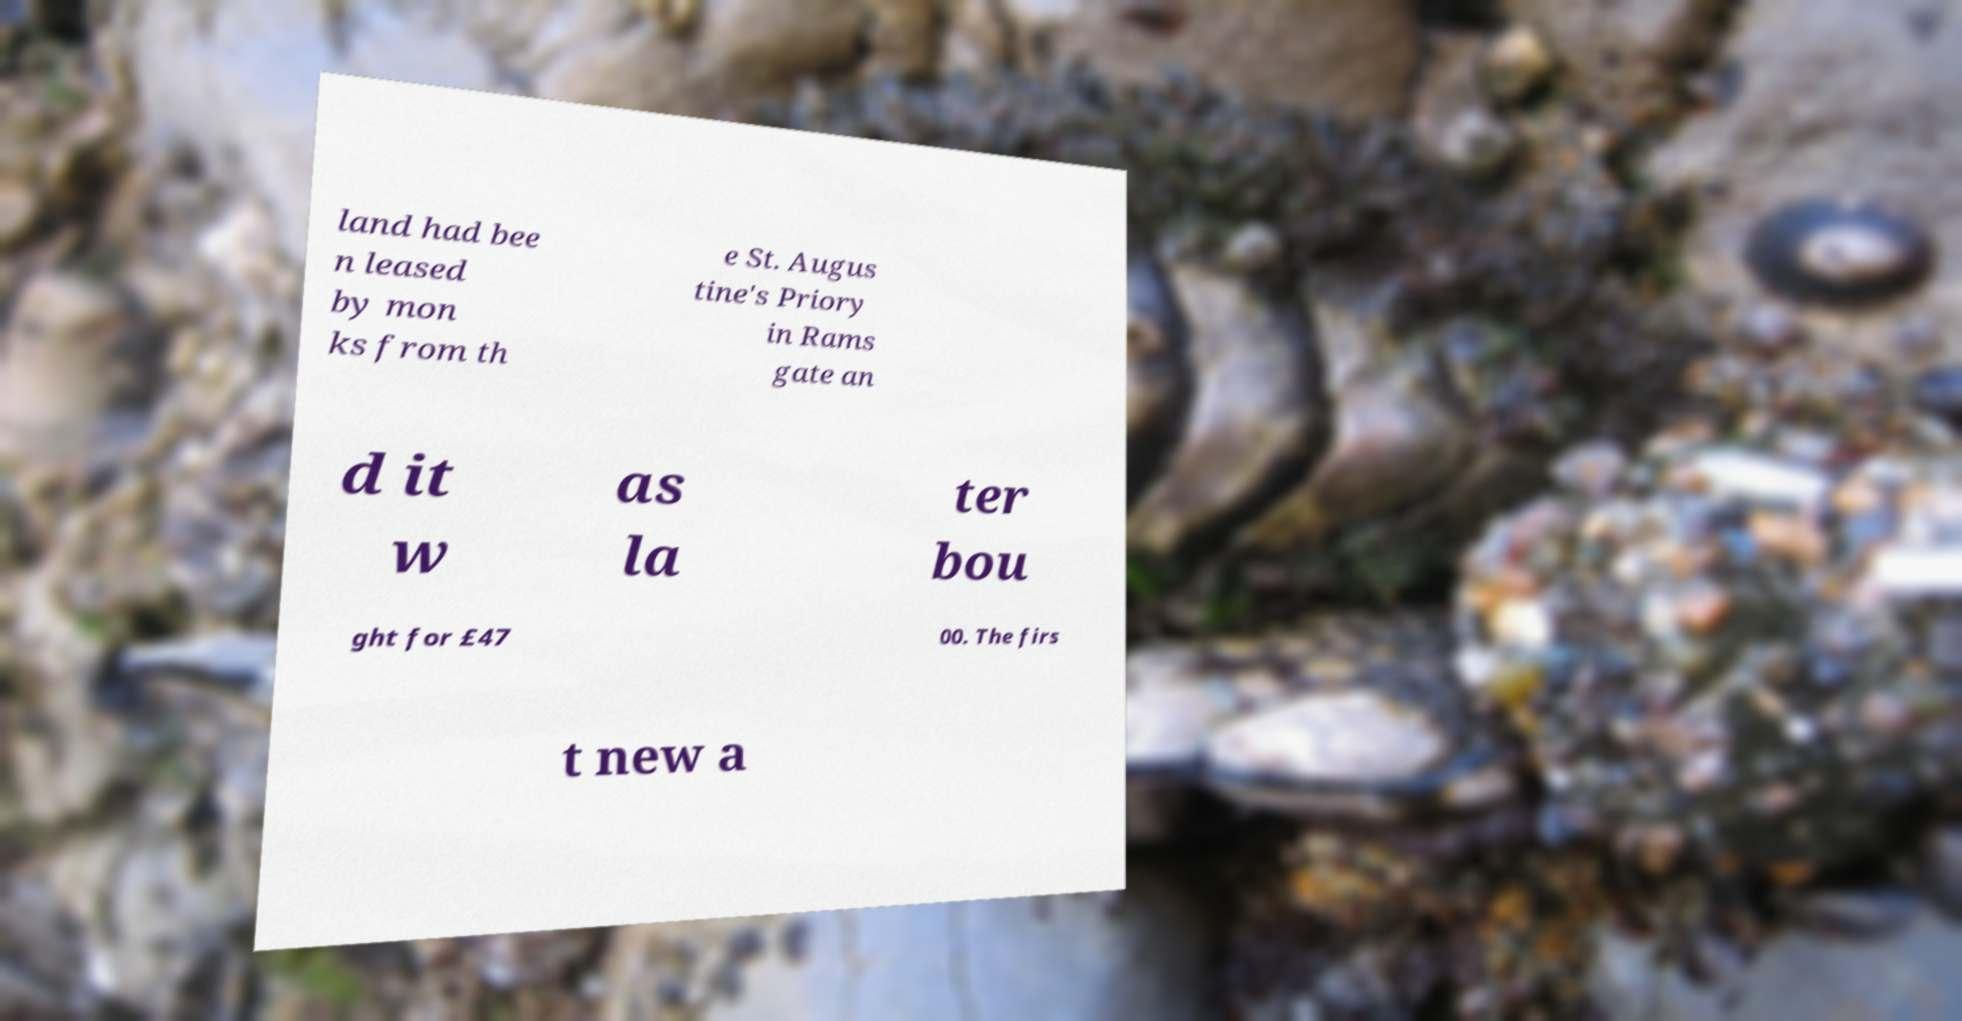Please identify and transcribe the text found in this image. land had bee n leased by mon ks from th e St. Augus tine's Priory in Rams gate an d it w as la ter bou ght for £47 00. The firs t new a 